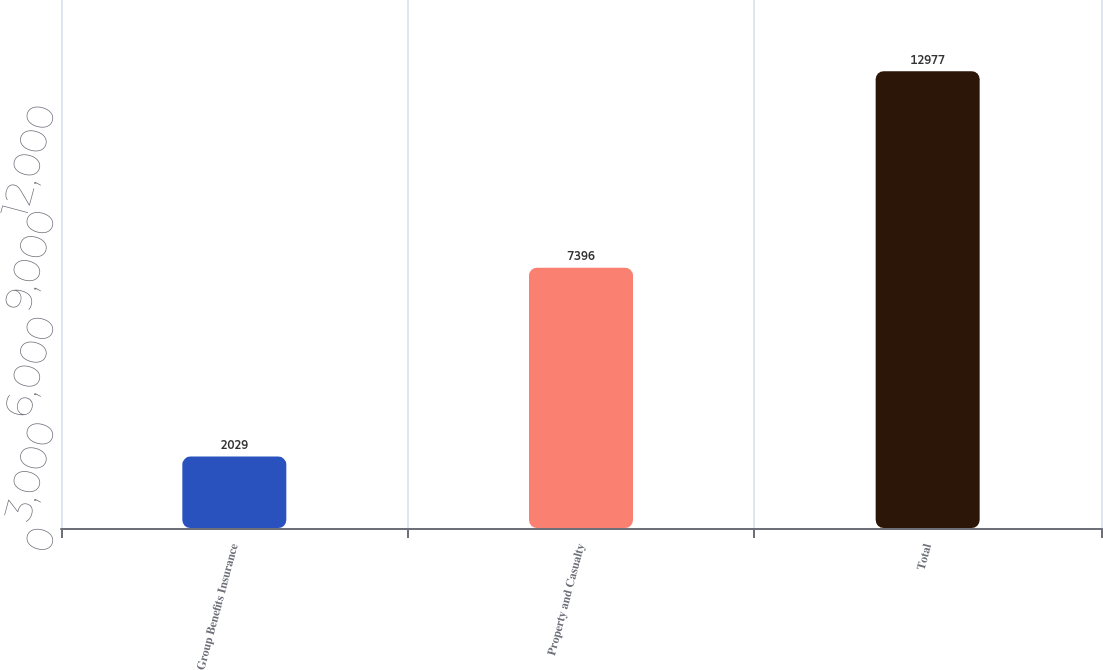Convert chart to OTSL. <chart><loc_0><loc_0><loc_500><loc_500><bar_chart><fcel>Group Benefits Insurance<fcel>Property and Casualty<fcel>Total<nl><fcel>2029<fcel>7396<fcel>12977<nl></chart> 